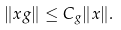Convert formula to latex. <formula><loc_0><loc_0><loc_500><loc_500>\| x g \| \leq C _ { g } \| x \| .</formula> 